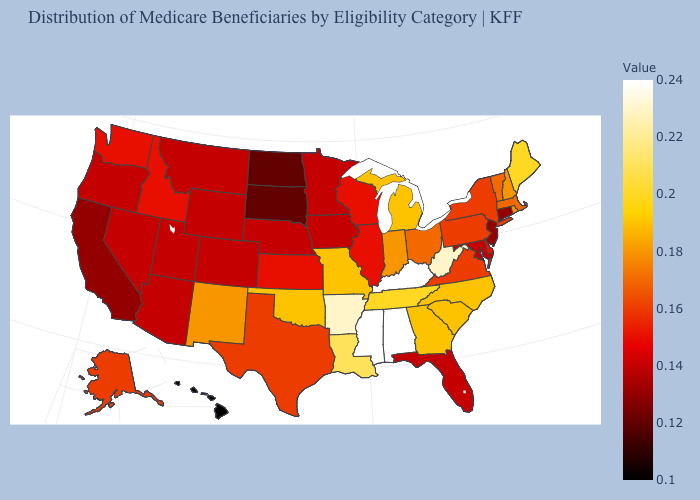Which states hav the highest value in the South?
Give a very brief answer. Alabama, Kentucky, Mississippi. Does the map have missing data?
Answer briefly. No. Is the legend a continuous bar?
Give a very brief answer. Yes. Does New Mexico have the highest value in the USA?
Give a very brief answer. No. Which states have the lowest value in the USA?
Short answer required. Hawaii. Which states have the lowest value in the USA?
Write a very short answer. Hawaii. Which states have the lowest value in the South?
Give a very brief answer. Florida, Maryland. Is the legend a continuous bar?
Concise answer only. Yes. Does the map have missing data?
Answer briefly. No. 